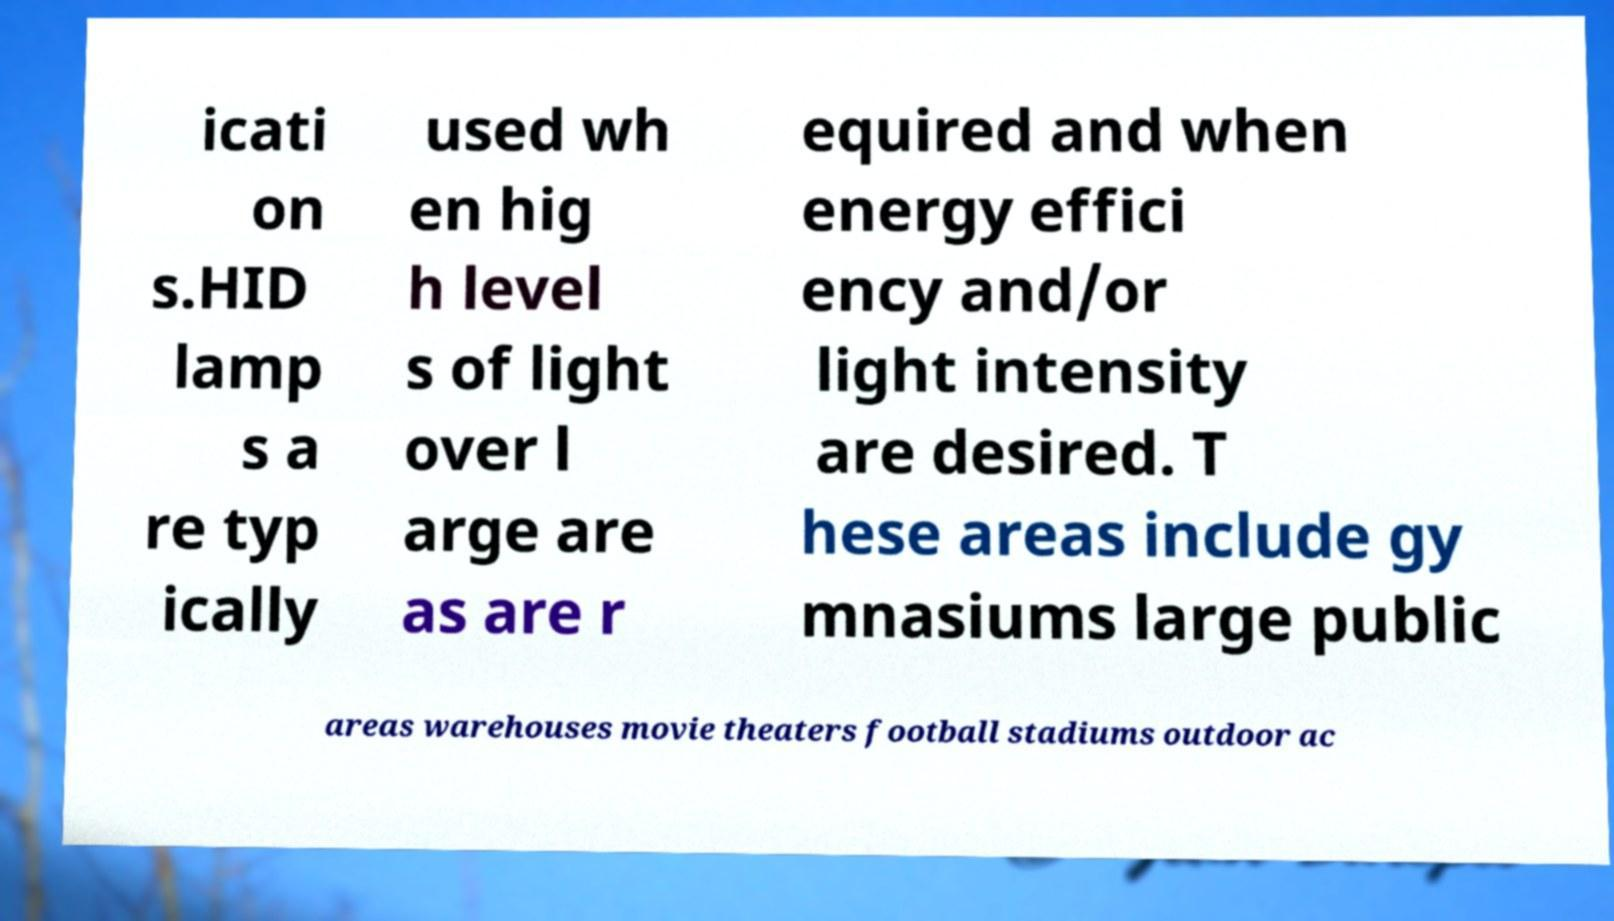What messages or text are displayed in this image? I need them in a readable, typed format. icati on s.HID lamp s a re typ ically used wh en hig h level s of light over l arge are as are r equired and when energy effici ency and/or light intensity are desired. T hese areas include gy mnasiums large public areas warehouses movie theaters football stadiums outdoor ac 